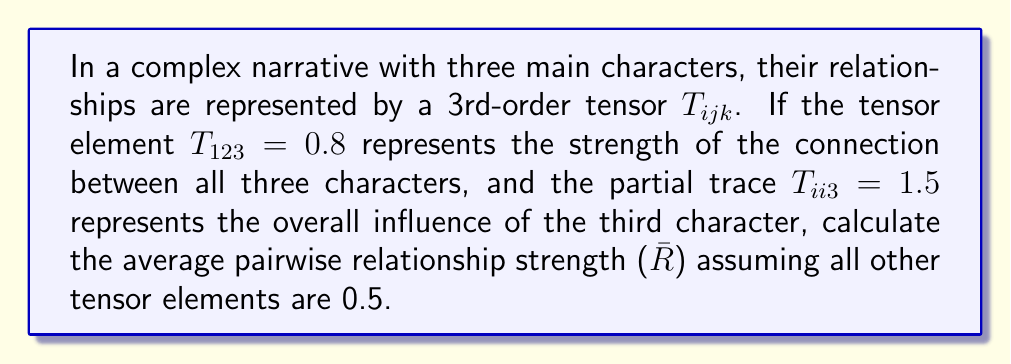Provide a solution to this math problem. To solve this problem, let's break it down into steps:

1) First, we need to understand what each part of the tensor represents:
   - $T_{ijk}$ is a 3rd-order tensor with dimensions 3x3x3
   - $T_{123} = 0.8$ is the strength of the three-way relationship
   - $T_{ii3} = 1.5$ is the partial trace, representing the third character's influence
   - All other elements are 0.5

2) The partial trace $T_{ii3}$ is the sum of the diagonal elements in the third "slice" of the tensor:
   $$T_{113} + T_{223} + T_{333} = 1.5$$

3) We know $T_{123} = 0.8$, so the other two elements in this sum must add up to 0.7:
   $$0.5 + 0.5 + T_{333} = 1.5$$
   $$T_{333} = 0.5$$

4) To calculate the average pairwise relationship strength, we need to sum all the pairwise relationships and divide by the number of pairs:
   $$\bar{R} = \frac{T_{12*} + T_{13*} + T_{23*}}{3}$$
   Where $T_{ij*}$ represents the sum of all elements with first two indices i and j.

5) For each pair:
   $T_{12*} = T_{121} + T_{122} + T_{123} = 0.5 + 0.5 + 0.8 = 1.8$
   $T_{13*} = T_{131} + T_{132} + T_{133} = 0.5 + 0.5 + 0.5 = 1.5$
   $T_{23*} = T_{231} + T_{232} + T_{233} = 0.5 + 0.5 + 0.5 = 1.5$

6) Now we can calculate the average:
   $$\bar{R} = \frac{1.8 + 1.5 + 1.5}{3} = \frac{4.8}{3} = 1.6$$
Answer: $\bar{R} = 1.6$ 